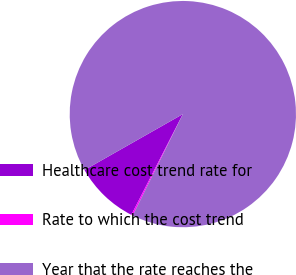Convert chart. <chart><loc_0><loc_0><loc_500><loc_500><pie_chart><fcel>Healthcare cost trend rate for<fcel>Rate to which the cost trend<fcel>Year that the rate reaches the<nl><fcel>9.25%<fcel>0.22%<fcel>90.52%<nl></chart> 